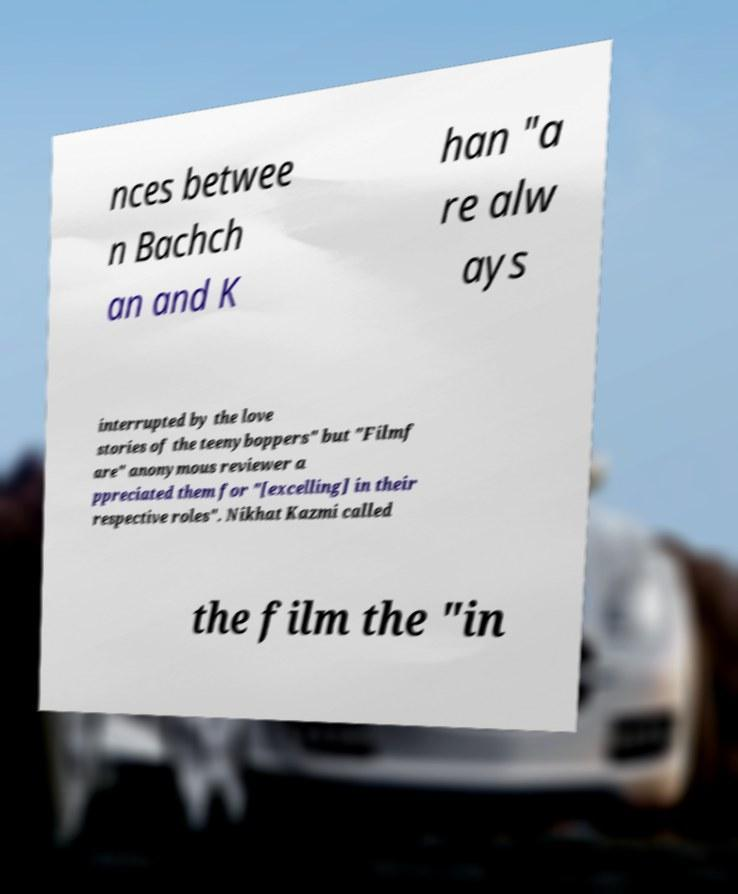Please read and relay the text visible in this image. What does it say? nces betwee n Bachch an and K han "a re alw ays interrupted by the love stories of the teenyboppers" but "Filmf are" anonymous reviewer a ppreciated them for "[excelling] in their respective roles". Nikhat Kazmi called the film the "in 